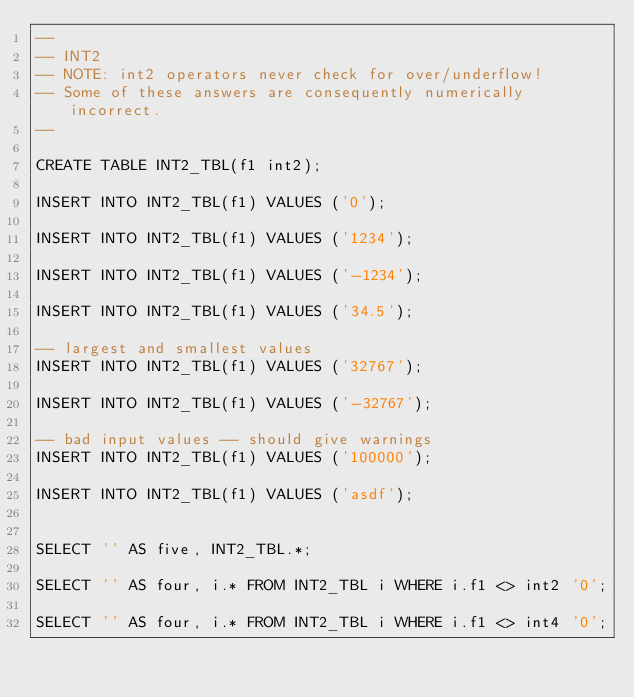<code> <loc_0><loc_0><loc_500><loc_500><_SQL_>--
-- INT2
-- NOTE: int2 operators never check for over/underflow!
-- Some of these answers are consequently numerically incorrect.
--

CREATE TABLE INT2_TBL(f1 int2);

INSERT INTO INT2_TBL(f1) VALUES ('0');

INSERT INTO INT2_TBL(f1) VALUES ('1234');

INSERT INTO INT2_TBL(f1) VALUES ('-1234');

INSERT INTO INT2_TBL(f1) VALUES ('34.5');

-- largest and smallest values 
INSERT INTO INT2_TBL(f1) VALUES ('32767');

INSERT INTO INT2_TBL(f1) VALUES ('-32767');

-- bad input values -- should give warnings 
INSERT INTO INT2_TBL(f1) VALUES ('100000');

INSERT INTO INT2_TBL(f1) VALUES ('asdf');


SELECT '' AS five, INT2_TBL.*;

SELECT '' AS four, i.* FROM INT2_TBL i WHERE i.f1 <> int2 '0';

SELECT '' AS four, i.* FROM INT2_TBL i WHERE i.f1 <> int4 '0';
</code> 